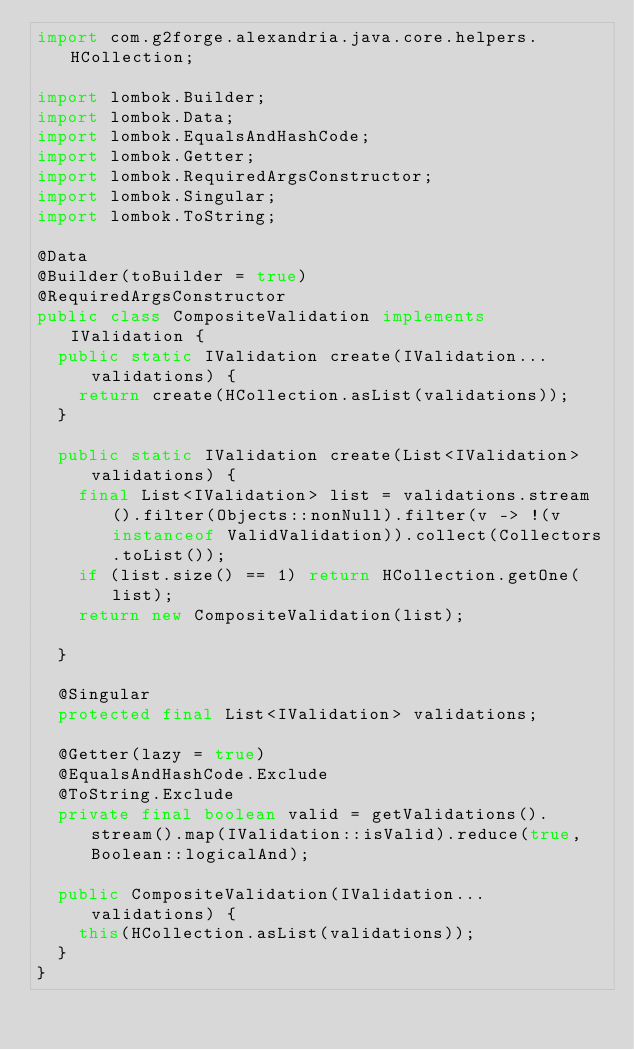Convert code to text. <code><loc_0><loc_0><loc_500><loc_500><_Java_>import com.g2forge.alexandria.java.core.helpers.HCollection;

import lombok.Builder;
import lombok.Data;
import lombok.EqualsAndHashCode;
import lombok.Getter;
import lombok.RequiredArgsConstructor;
import lombok.Singular;
import lombok.ToString;

@Data
@Builder(toBuilder = true)
@RequiredArgsConstructor
public class CompositeValidation implements IValidation {
	public static IValidation create(IValidation... validations) {
		return create(HCollection.asList(validations));
	}

	public static IValidation create(List<IValidation> validations) {
		final List<IValidation> list = validations.stream().filter(Objects::nonNull).filter(v -> !(v instanceof ValidValidation)).collect(Collectors.toList());
		if (list.size() == 1) return HCollection.getOne(list);
		return new CompositeValidation(list);

	}

	@Singular
	protected final List<IValidation> validations;

	@Getter(lazy = true)
	@EqualsAndHashCode.Exclude
	@ToString.Exclude
	private final boolean valid = getValidations().stream().map(IValidation::isValid).reduce(true, Boolean::logicalAnd);

	public CompositeValidation(IValidation... validations) {
		this(HCollection.asList(validations));
	}
}
</code> 